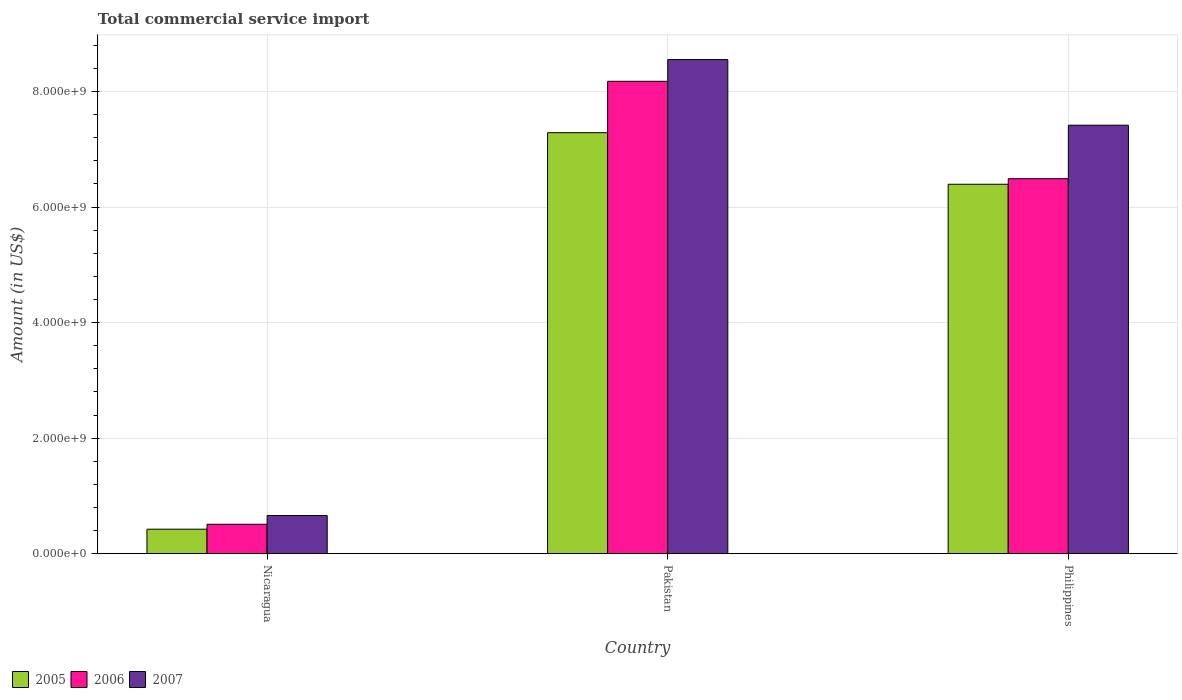How many bars are there on the 3rd tick from the right?
Your answer should be compact. 3. What is the label of the 1st group of bars from the left?
Provide a succinct answer. Nicaragua. What is the total commercial service import in 2005 in Philippines?
Provide a succinct answer. 6.40e+09. Across all countries, what is the maximum total commercial service import in 2007?
Offer a terse response. 8.55e+09. Across all countries, what is the minimum total commercial service import in 2006?
Offer a terse response. 5.09e+08. In which country was the total commercial service import in 2006 minimum?
Your response must be concise. Nicaragua. What is the total total commercial service import in 2006 in the graph?
Your answer should be compact. 1.52e+1. What is the difference between the total commercial service import in 2007 in Nicaragua and that in Philippines?
Offer a terse response. -6.76e+09. What is the difference between the total commercial service import in 2005 in Nicaragua and the total commercial service import in 2006 in Philippines?
Your answer should be compact. -6.07e+09. What is the average total commercial service import in 2005 per country?
Offer a very short reply. 4.70e+09. What is the difference between the total commercial service import of/in 2005 and total commercial service import of/in 2007 in Pakistan?
Your answer should be compact. -1.27e+09. What is the ratio of the total commercial service import in 2005 in Nicaragua to that in Pakistan?
Give a very brief answer. 0.06. Is the difference between the total commercial service import in 2005 in Nicaragua and Philippines greater than the difference between the total commercial service import in 2007 in Nicaragua and Philippines?
Offer a terse response. Yes. What is the difference between the highest and the second highest total commercial service import in 2005?
Ensure brevity in your answer.  8.93e+08. What is the difference between the highest and the lowest total commercial service import in 2007?
Keep it short and to the point. 7.89e+09. What does the 3rd bar from the right in Philippines represents?
Ensure brevity in your answer.  2005. Is it the case that in every country, the sum of the total commercial service import in 2006 and total commercial service import in 2005 is greater than the total commercial service import in 2007?
Your answer should be compact. Yes. How many bars are there?
Keep it short and to the point. 9. Are all the bars in the graph horizontal?
Your answer should be very brief. No. Are the values on the major ticks of Y-axis written in scientific E-notation?
Your answer should be compact. Yes. How many legend labels are there?
Keep it short and to the point. 3. What is the title of the graph?
Make the answer very short. Total commercial service import. Does "1987" appear as one of the legend labels in the graph?
Your response must be concise. No. What is the Amount (in US$) of 2005 in Nicaragua?
Give a very brief answer. 4.24e+08. What is the Amount (in US$) in 2006 in Nicaragua?
Your answer should be very brief. 5.09e+08. What is the Amount (in US$) of 2007 in Nicaragua?
Your answer should be very brief. 6.60e+08. What is the Amount (in US$) of 2005 in Pakistan?
Keep it short and to the point. 7.29e+09. What is the Amount (in US$) of 2006 in Pakistan?
Your answer should be compact. 8.18e+09. What is the Amount (in US$) of 2007 in Pakistan?
Make the answer very short. 8.55e+09. What is the Amount (in US$) in 2005 in Philippines?
Ensure brevity in your answer.  6.40e+09. What is the Amount (in US$) of 2006 in Philippines?
Make the answer very short. 6.49e+09. What is the Amount (in US$) in 2007 in Philippines?
Offer a very short reply. 7.42e+09. Across all countries, what is the maximum Amount (in US$) of 2005?
Provide a short and direct response. 7.29e+09. Across all countries, what is the maximum Amount (in US$) in 2006?
Keep it short and to the point. 8.18e+09. Across all countries, what is the maximum Amount (in US$) of 2007?
Offer a very short reply. 8.55e+09. Across all countries, what is the minimum Amount (in US$) in 2005?
Offer a very short reply. 4.24e+08. Across all countries, what is the minimum Amount (in US$) of 2006?
Offer a very short reply. 5.09e+08. Across all countries, what is the minimum Amount (in US$) in 2007?
Your response must be concise. 6.60e+08. What is the total Amount (in US$) in 2005 in the graph?
Ensure brevity in your answer.  1.41e+1. What is the total Amount (in US$) of 2006 in the graph?
Give a very brief answer. 1.52e+1. What is the total Amount (in US$) of 2007 in the graph?
Your answer should be very brief. 1.66e+1. What is the difference between the Amount (in US$) of 2005 in Nicaragua and that in Pakistan?
Your answer should be compact. -6.86e+09. What is the difference between the Amount (in US$) in 2006 in Nicaragua and that in Pakistan?
Offer a terse response. -7.67e+09. What is the difference between the Amount (in US$) in 2007 in Nicaragua and that in Pakistan?
Offer a terse response. -7.89e+09. What is the difference between the Amount (in US$) of 2005 in Nicaragua and that in Philippines?
Provide a short and direct response. -5.97e+09. What is the difference between the Amount (in US$) of 2006 in Nicaragua and that in Philippines?
Keep it short and to the point. -5.98e+09. What is the difference between the Amount (in US$) of 2007 in Nicaragua and that in Philippines?
Your answer should be compact. -6.76e+09. What is the difference between the Amount (in US$) in 2005 in Pakistan and that in Philippines?
Give a very brief answer. 8.93e+08. What is the difference between the Amount (in US$) of 2006 in Pakistan and that in Philippines?
Your response must be concise. 1.69e+09. What is the difference between the Amount (in US$) in 2007 in Pakistan and that in Philippines?
Make the answer very short. 1.14e+09. What is the difference between the Amount (in US$) of 2005 in Nicaragua and the Amount (in US$) of 2006 in Pakistan?
Keep it short and to the point. -7.75e+09. What is the difference between the Amount (in US$) of 2005 in Nicaragua and the Amount (in US$) of 2007 in Pakistan?
Offer a terse response. -8.13e+09. What is the difference between the Amount (in US$) of 2006 in Nicaragua and the Amount (in US$) of 2007 in Pakistan?
Offer a terse response. -8.04e+09. What is the difference between the Amount (in US$) in 2005 in Nicaragua and the Amount (in US$) in 2006 in Philippines?
Offer a very short reply. -6.07e+09. What is the difference between the Amount (in US$) of 2005 in Nicaragua and the Amount (in US$) of 2007 in Philippines?
Ensure brevity in your answer.  -6.99e+09. What is the difference between the Amount (in US$) in 2006 in Nicaragua and the Amount (in US$) in 2007 in Philippines?
Keep it short and to the point. -6.91e+09. What is the difference between the Amount (in US$) in 2005 in Pakistan and the Amount (in US$) in 2006 in Philippines?
Your answer should be very brief. 7.97e+08. What is the difference between the Amount (in US$) of 2005 in Pakistan and the Amount (in US$) of 2007 in Philippines?
Keep it short and to the point. -1.30e+08. What is the difference between the Amount (in US$) of 2006 in Pakistan and the Amount (in US$) of 2007 in Philippines?
Offer a very short reply. 7.60e+08. What is the average Amount (in US$) in 2005 per country?
Make the answer very short. 4.70e+09. What is the average Amount (in US$) in 2006 per country?
Make the answer very short. 5.06e+09. What is the average Amount (in US$) in 2007 per country?
Keep it short and to the point. 5.54e+09. What is the difference between the Amount (in US$) of 2005 and Amount (in US$) of 2006 in Nicaragua?
Offer a terse response. -8.55e+07. What is the difference between the Amount (in US$) in 2005 and Amount (in US$) in 2007 in Nicaragua?
Offer a terse response. -2.36e+08. What is the difference between the Amount (in US$) of 2006 and Amount (in US$) of 2007 in Nicaragua?
Your response must be concise. -1.51e+08. What is the difference between the Amount (in US$) in 2005 and Amount (in US$) in 2006 in Pakistan?
Offer a very short reply. -8.89e+08. What is the difference between the Amount (in US$) in 2005 and Amount (in US$) in 2007 in Pakistan?
Your response must be concise. -1.27e+09. What is the difference between the Amount (in US$) of 2006 and Amount (in US$) of 2007 in Pakistan?
Provide a short and direct response. -3.76e+08. What is the difference between the Amount (in US$) of 2005 and Amount (in US$) of 2006 in Philippines?
Provide a short and direct response. -9.62e+07. What is the difference between the Amount (in US$) of 2005 and Amount (in US$) of 2007 in Philippines?
Offer a very short reply. -1.02e+09. What is the difference between the Amount (in US$) in 2006 and Amount (in US$) in 2007 in Philippines?
Make the answer very short. -9.26e+08. What is the ratio of the Amount (in US$) in 2005 in Nicaragua to that in Pakistan?
Offer a very short reply. 0.06. What is the ratio of the Amount (in US$) in 2006 in Nicaragua to that in Pakistan?
Keep it short and to the point. 0.06. What is the ratio of the Amount (in US$) of 2007 in Nicaragua to that in Pakistan?
Offer a very short reply. 0.08. What is the ratio of the Amount (in US$) in 2005 in Nicaragua to that in Philippines?
Give a very brief answer. 0.07. What is the ratio of the Amount (in US$) in 2006 in Nicaragua to that in Philippines?
Keep it short and to the point. 0.08. What is the ratio of the Amount (in US$) of 2007 in Nicaragua to that in Philippines?
Your answer should be compact. 0.09. What is the ratio of the Amount (in US$) of 2005 in Pakistan to that in Philippines?
Offer a very short reply. 1.14. What is the ratio of the Amount (in US$) of 2006 in Pakistan to that in Philippines?
Provide a short and direct response. 1.26. What is the ratio of the Amount (in US$) in 2007 in Pakistan to that in Philippines?
Offer a terse response. 1.15. What is the difference between the highest and the second highest Amount (in US$) in 2005?
Offer a terse response. 8.93e+08. What is the difference between the highest and the second highest Amount (in US$) in 2006?
Your answer should be compact. 1.69e+09. What is the difference between the highest and the second highest Amount (in US$) in 2007?
Your answer should be very brief. 1.14e+09. What is the difference between the highest and the lowest Amount (in US$) in 2005?
Your answer should be very brief. 6.86e+09. What is the difference between the highest and the lowest Amount (in US$) of 2006?
Offer a terse response. 7.67e+09. What is the difference between the highest and the lowest Amount (in US$) in 2007?
Your answer should be compact. 7.89e+09. 